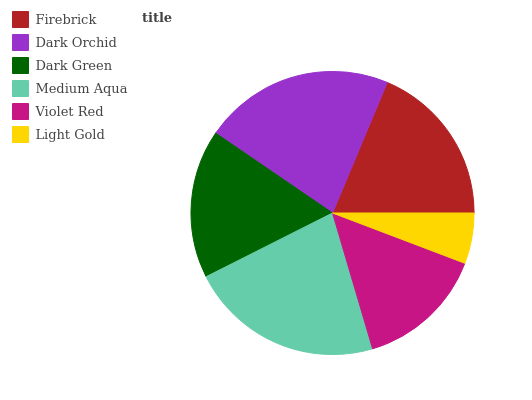Is Light Gold the minimum?
Answer yes or no. Yes. Is Medium Aqua the maximum?
Answer yes or no. Yes. Is Dark Orchid the minimum?
Answer yes or no. No. Is Dark Orchid the maximum?
Answer yes or no. No. Is Dark Orchid greater than Firebrick?
Answer yes or no. Yes. Is Firebrick less than Dark Orchid?
Answer yes or no. Yes. Is Firebrick greater than Dark Orchid?
Answer yes or no. No. Is Dark Orchid less than Firebrick?
Answer yes or no. No. Is Firebrick the high median?
Answer yes or no. Yes. Is Dark Green the low median?
Answer yes or no. Yes. Is Light Gold the high median?
Answer yes or no. No. Is Firebrick the low median?
Answer yes or no. No. 